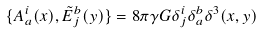Convert formula to latex. <formula><loc_0><loc_0><loc_500><loc_500>\{ A ^ { i } _ { a } ( x ) , \tilde { E } ^ { b } _ { j } ( y ) \} = 8 \pi \gamma G \delta ^ { i } _ { j } \delta ^ { b } _ { a } \delta ^ { 3 } ( x , y )</formula> 